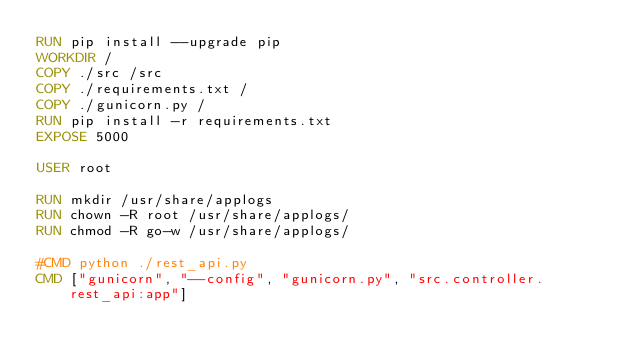Convert code to text. <code><loc_0><loc_0><loc_500><loc_500><_Dockerfile_>RUN pip install --upgrade pip
WORKDIR /
COPY ./src /src
COPY ./requirements.txt /
COPY ./gunicorn.py /
RUN pip install -r requirements.txt
EXPOSE 5000

USER root

RUN mkdir /usr/share/applogs
RUN chown -R root /usr/share/applogs/
RUN chmod -R go-w /usr/share/applogs/

#CMD python ./rest_api.py
CMD ["gunicorn", "--config", "gunicorn.py", "src.controller.rest_api:app"]</code> 